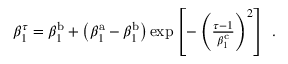<formula> <loc_0><loc_0><loc_500><loc_500>\begin{array} { r } { \beta _ { 1 } ^ { \tau } = \beta _ { 1 } ^ { b } + \left ( \beta _ { 1 } ^ { a } - \beta _ { 1 } ^ { b } \right ) \exp \left [ - \left ( \frac { \tau - 1 } { \beta _ { 1 } ^ { c } } \right ) ^ { 2 } \right ] \ . } \end{array}</formula> 